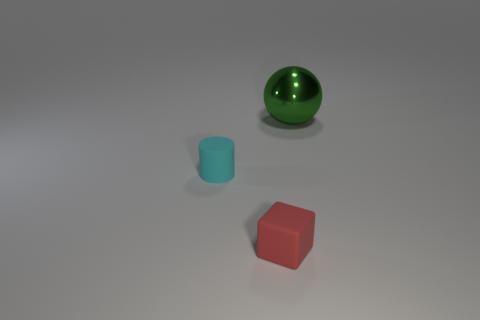What is the color of the small matte thing that is on the right side of the tiny rubber object that is behind the small red rubber cube?
Make the answer very short. Red. How many objects are objects in front of the cyan matte cylinder or matte objects behind the red matte object?
Give a very brief answer. 2. Do the metal sphere and the matte cube have the same size?
Offer a terse response. No. Is there any other thing that is the same size as the cyan cylinder?
Ensure brevity in your answer.  Yes. There is a tiny matte object on the left side of the small cube; is its shape the same as the tiny matte object that is to the right of the cyan cylinder?
Offer a terse response. No. How big is the red rubber object?
Your answer should be very brief. Small. What is the material of the object to the right of the thing that is in front of the matte thing to the left of the rubber cube?
Your answer should be compact. Metal. What number of cyan objects are either spheres or rubber objects?
Provide a succinct answer. 1. There is a object to the right of the red cube; what is it made of?
Provide a succinct answer. Metal. Are the small thing behind the red cube and the big green sphere made of the same material?
Make the answer very short. No. 